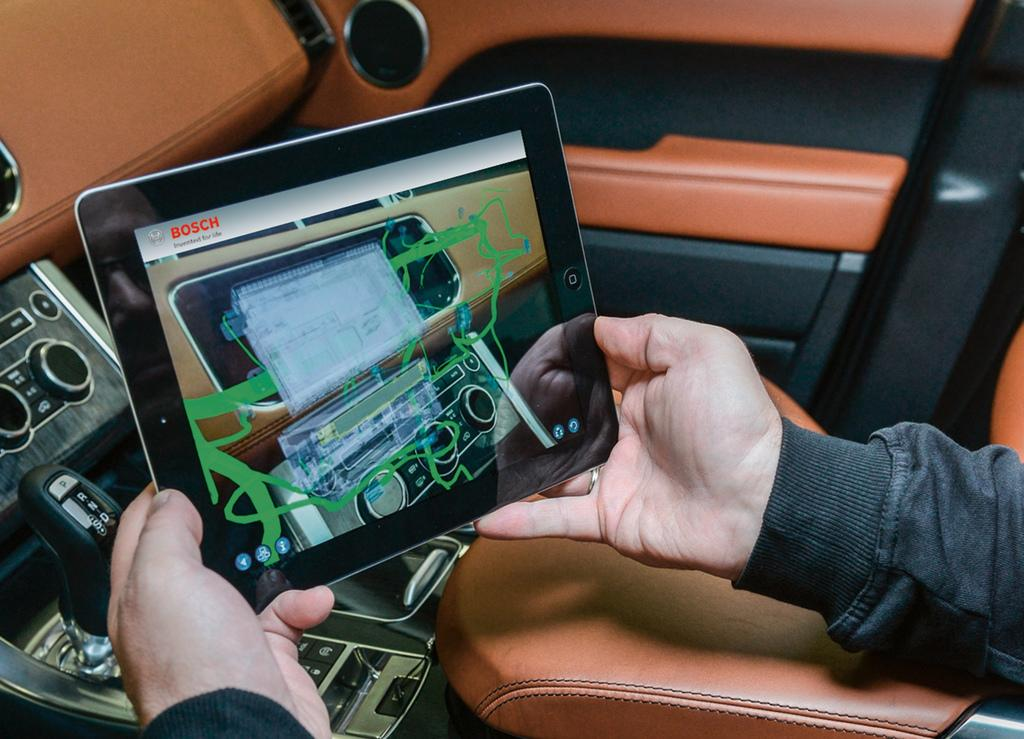Who is present in the image? There is a person in the image. What is the person holding in the image? The person is holding a tab. Where is the person located in the image? The person is inside a car. What can be found in the car? There is a gear rod, buttons, and a side door in the car. What direction is the snail moving in the image? There is no snail present in the image, so it is not possible to determine the direction in which it might be moving. 